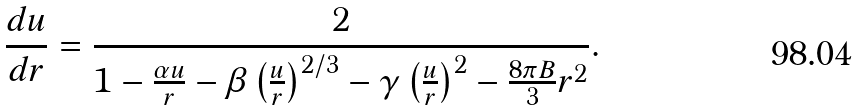Convert formula to latex. <formula><loc_0><loc_0><loc_500><loc_500>\frac { d u } { d r } = \frac { 2 } { 1 - \frac { \alpha u } { r } - \beta \left ( \frac { u } { r } \right ) ^ { 2 / 3 } - \gamma \left ( \frac { u } { r } \right ) ^ { 2 } - \frac { 8 \pi B } { 3 } r ^ { 2 } } .</formula> 